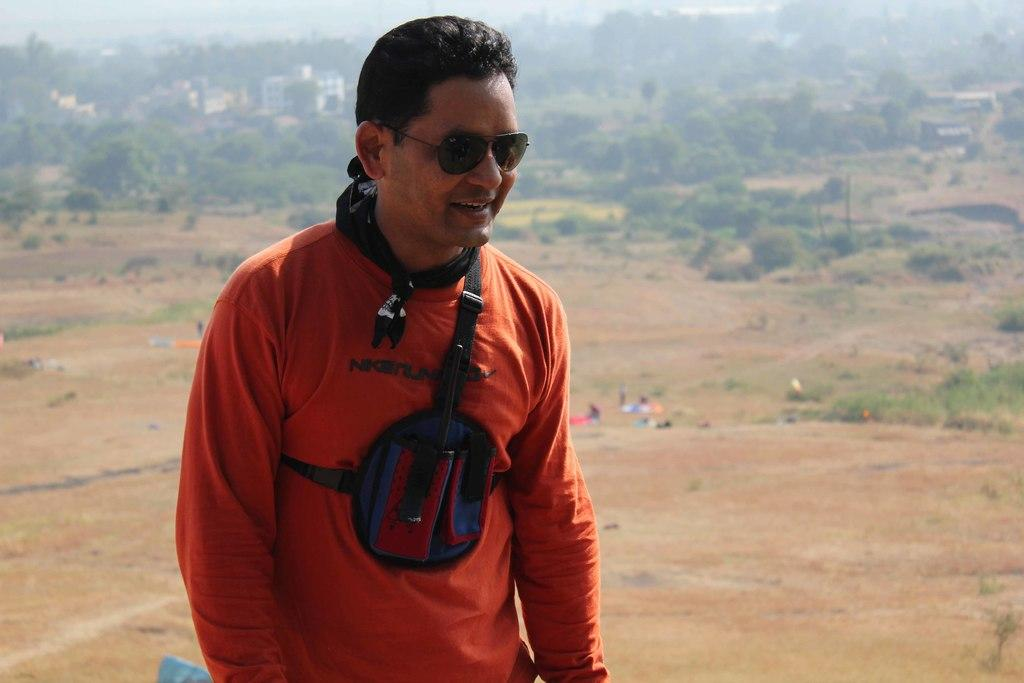What is the main subject of the image? There is a man standing in the image. What is the man wearing that is visible in the image? The man is wearing sunglasses. What can be seen in the background of the image? There are trees and buildings visible in the background of the image. What else is present on the ground in the image? There are people on the ground in the image. Reasoning: Let's think step by step by following the given facts step by step to produce the conversation. We start by identifying the main subject of the image, which is the man standing. Then, we describe the man's appearance by mentioning that he is wearing sunglasses. Next, we focus on the background of the image, noting the presence of trees and buildings. Finally, we mention the presence of other people on the ground. Absurd Question/Answer: What type of learning is the man teaching in the image? There is no indication in the image that the man is teaching any type of learning. What type of hope can be seen in the man's expression in the image? There is no indication in the image of the man's expression or any emotion related to hope. 